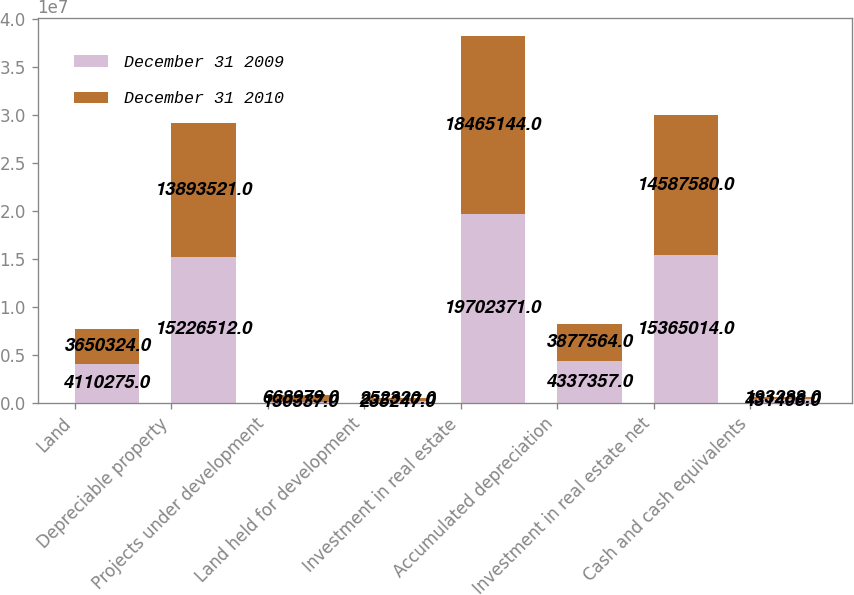<chart> <loc_0><loc_0><loc_500><loc_500><stacked_bar_chart><ecel><fcel>Land<fcel>Depreciable property<fcel>Projects under development<fcel>Land held for development<fcel>Investment in real estate<fcel>Accumulated depreciation<fcel>Investment in real estate net<fcel>Cash and cash equivalents<nl><fcel>December 31 2009<fcel>4.11028e+06<fcel>1.52265e+07<fcel>130337<fcel>235247<fcel>1.97024e+07<fcel>4.33736e+06<fcel>1.5365e+07<fcel>431408<nl><fcel>December 31 2010<fcel>3.65032e+06<fcel>1.38935e+07<fcel>668979<fcel>252320<fcel>1.84651e+07<fcel>3.87756e+06<fcel>1.45876e+07<fcel>193288<nl></chart> 